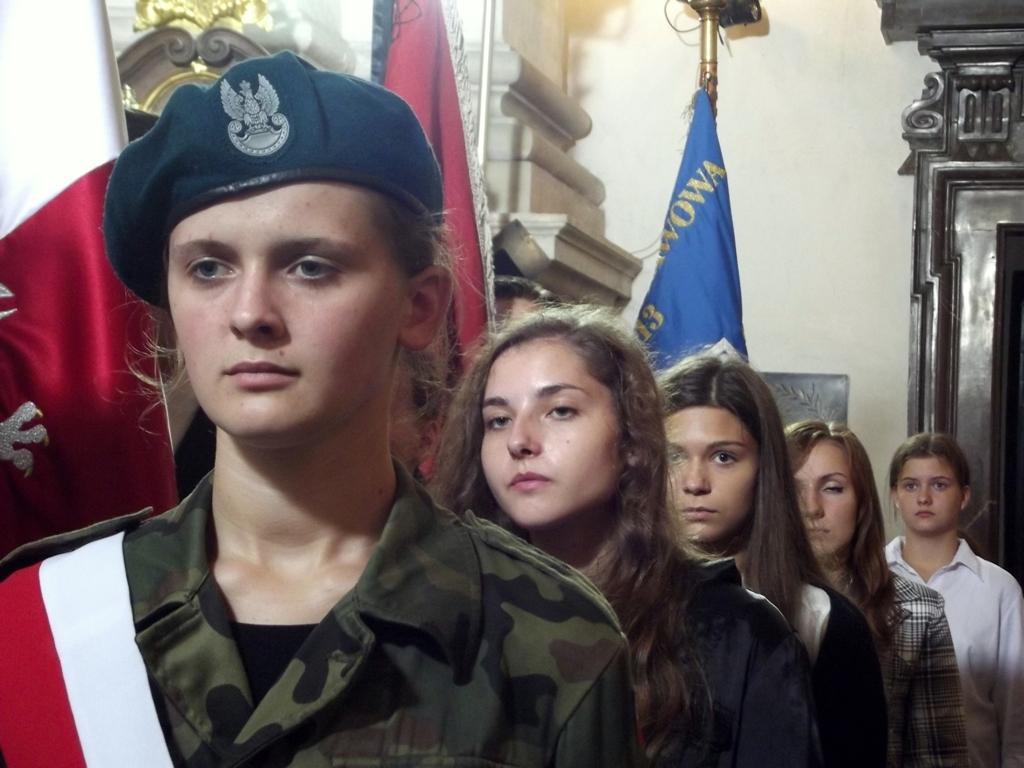Describe this image in one or two sentences. There are five ladies standing in a line. First lady is wearing a cap. In the back there are flags. Also there is a wall. On the right side we can see a wooden structure. 